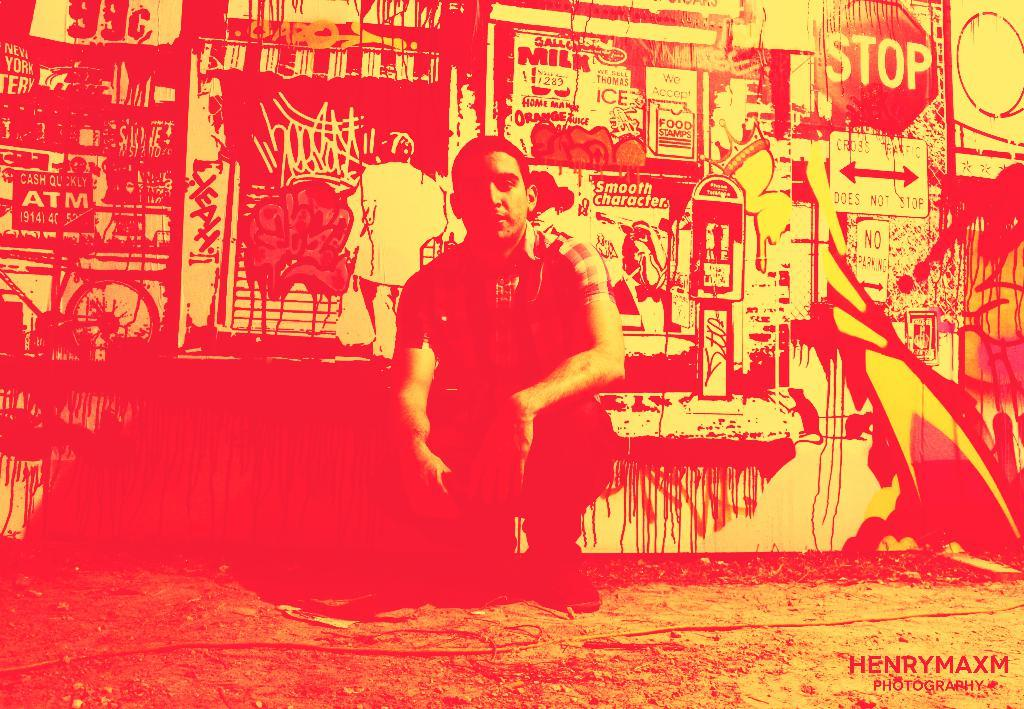<image>
Present a compact description of the photo's key features. HenryMaxm photography includes a guy posing for a picture 